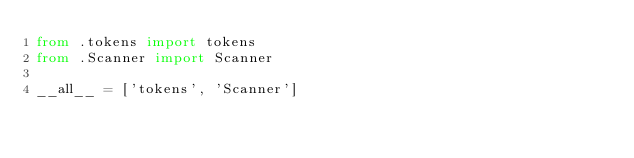<code> <loc_0><loc_0><loc_500><loc_500><_Python_>from .tokens import tokens
from .Scanner import Scanner

__all__ = ['tokens', 'Scanner']
</code> 